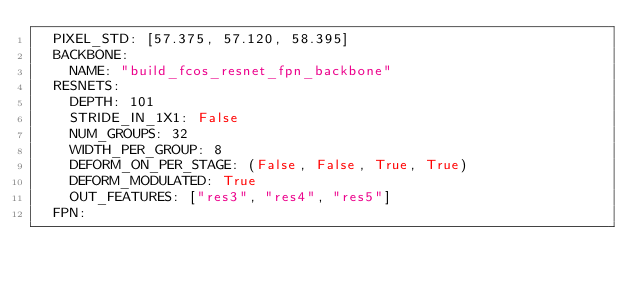Convert code to text. <code><loc_0><loc_0><loc_500><loc_500><_YAML_>  PIXEL_STD: [57.375, 57.120, 58.395]
  BACKBONE:
    NAME: "build_fcos_resnet_fpn_backbone"
  RESNETS:
    DEPTH: 101
    STRIDE_IN_1X1: False
    NUM_GROUPS: 32
    WIDTH_PER_GROUP: 8
    DEFORM_ON_PER_STAGE: (False, False, True, True)
    DEFORM_MODULATED: True
    OUT_FEATURES: ["res3", "res4", "res5"]
  FPN:</code> 